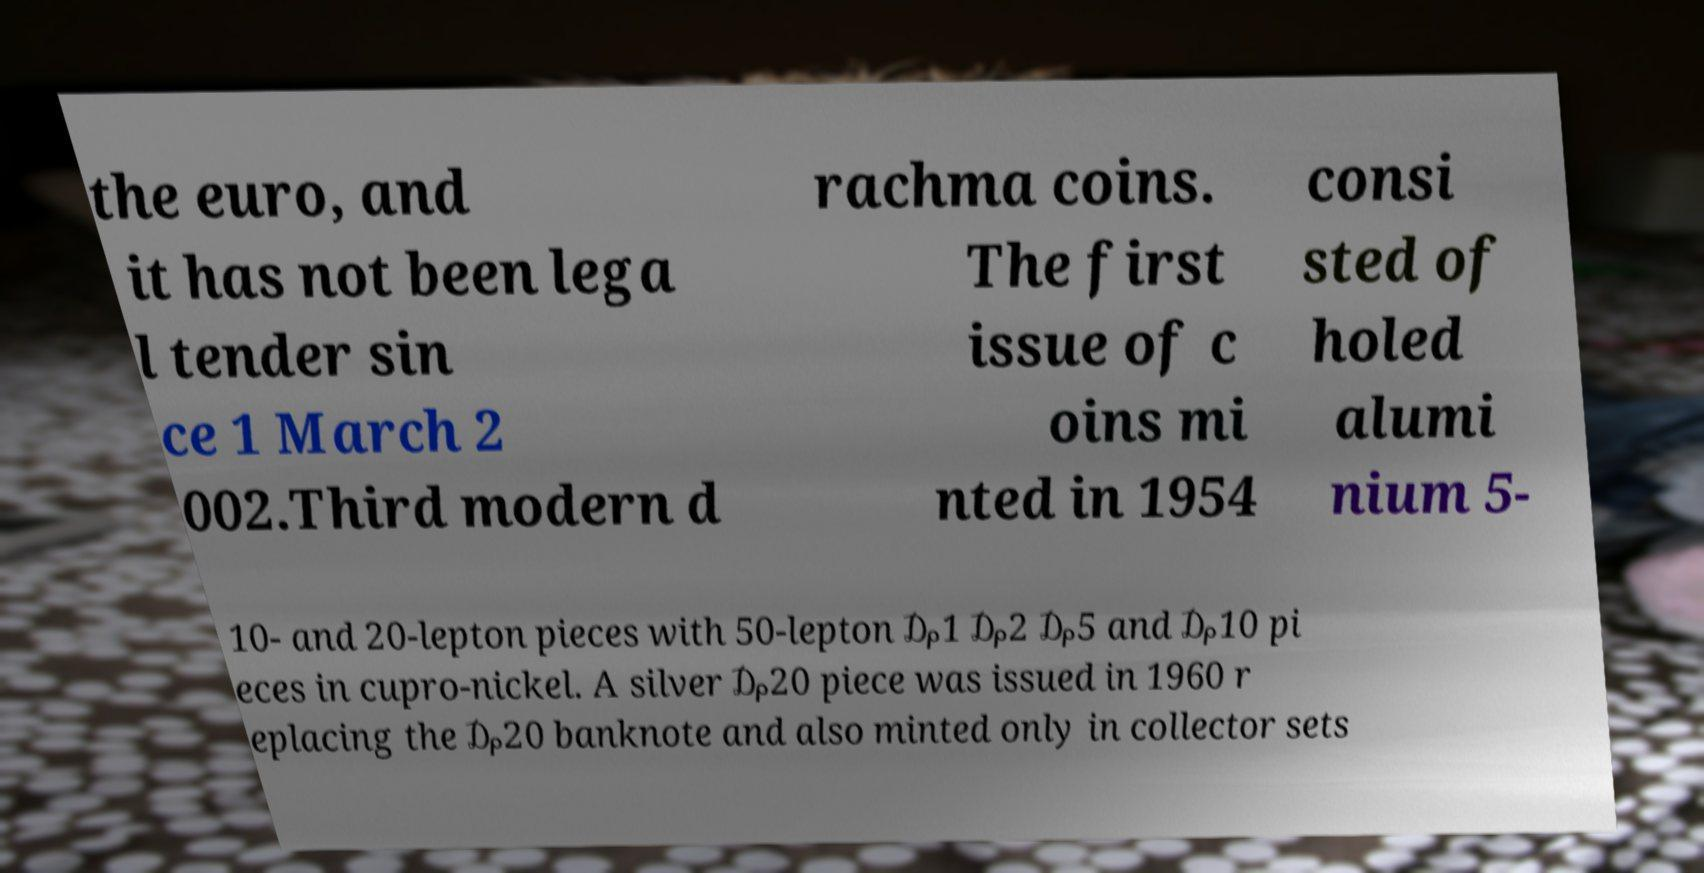Could you assist in decoding the text presented in this image and type it out clearly? the euro, and it has not been lega l tender sin ce 1 March 2 002.Third modern d rachma coins. The first issue of c oins mi nted in 1954 consi sted of holed alumi nium 5- 10- and 20-lepton pieces with 50-lepton ₯1 ₯2 ₯5 and ₯10 pi eces in cupro-nickel. A silver ₯20 piece was issued in 1960 r eplacing the ₯20 banknote and also minted only in collector sets 